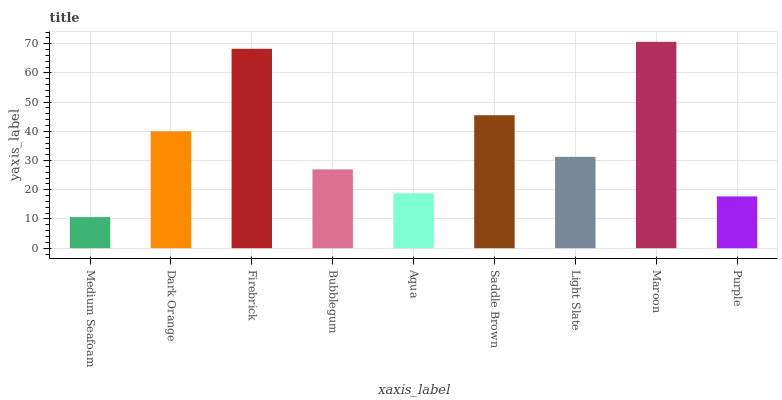Is Medium Seafoam the minimum?
Answer yes or no. Yes. Is Maroon the maximum?
Answer yes or no. Yes. Is Dark Orange the minimum?
Answer yes or no. No. Is Dark Orange the maximum?
Answer yes or no. No. Is Dark Orange greater than Medium Seafoam?
Answer yes or no. Yes. Is Medium Seafoam less than Dark Orange?
Answer yes or no. Yes. Is Medium Seafoam greater than Dark Orange?
Answer yes or no. No. Is Dark Orange less than Medium Seafoam?
Answer yes or no. No. Is Light Slate the high median?
Answer yes or no. Yes. Is Light Slate the low median?
Answer yes or no. Yes. Is Purple the high median?
Answer yes or no. No. Is Firebrick the low median?
Answer yes or no. No. 